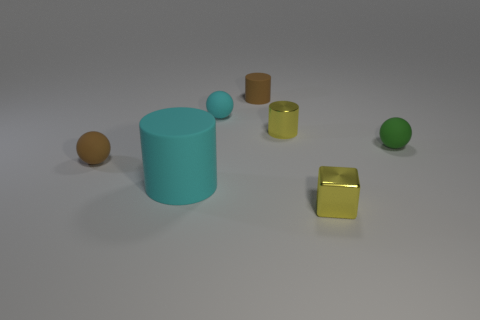Is the tiny cube the same color as the small metallic cylinder?
Provide a short and direct response. Yes. What is the shape of the yellow thing to the right of the small yellow metallic thing that is behind the yellow shiny object in front of the small green matte thing?
Your answer should be very brief. Cube. What is the shape of the matte thing to the right of the small rubber cylinder?
Give a very brief answer. Sphere. Does the small cyan ball have the same material as the cyan thing that is in front of the yellow metallic cylinder?
Give a very brief answer. Yes. How many other objects are the same shape as the green object?
Make the answer very short. 2. There is a metallic block; is its color the same as the shiny object that is behind the cyan cylinder?
Make the answer very short. Yes. What is the shape of the yellow thing that is to the left of the tiny yellow thing in front of the small green thing?
Your answer should be compact. Cylinder. What size is the other matte thing that is the same color as the large object?
Keep it short and to the point. Small. Does the tiny shiny thing that is behind the tiny green matte object have the same shape as the big matte object?
Your answer should be very brief. Yes. Are there more big cyan matte things behind the green rubber object than small green spheres that are in front of the tiny brown ball?
Offer a very short reply. No. 